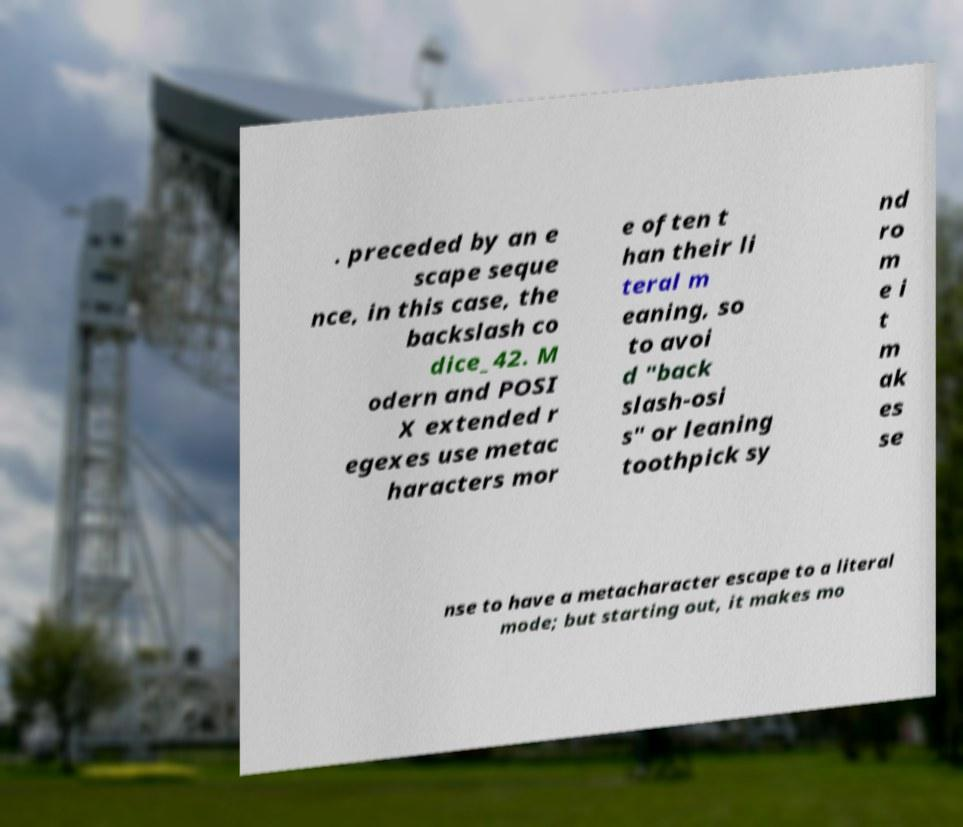For documentation purposes, I need the text within this image transcribed. Could you provide that? . preceded by an e scape seque nce, in this case, the backslash co dice_42. M odern and POSI X extended r egexes use metac haracters mor e often t han their li teral m eaning, so to avoi d "back slash-osi s" or leaning toothpick sy nd ro m e i t m ak es se nse to have a metacharacter escape to a literal mode; but starting out, it makes mo 